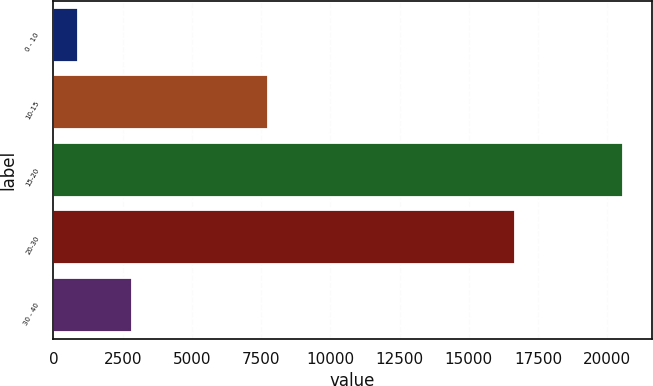<chart> <loc_0><loc_0><loc_500><loc_500><bar_chart><fcel>0 - 10<fcel>10-15<fcel>15-20<fcel>20-30<fcel>30 - 40<nl><fcel>882<fcel>7757<fcel>20568<fcel>16656<fcel>2850.6<nl></chart> 